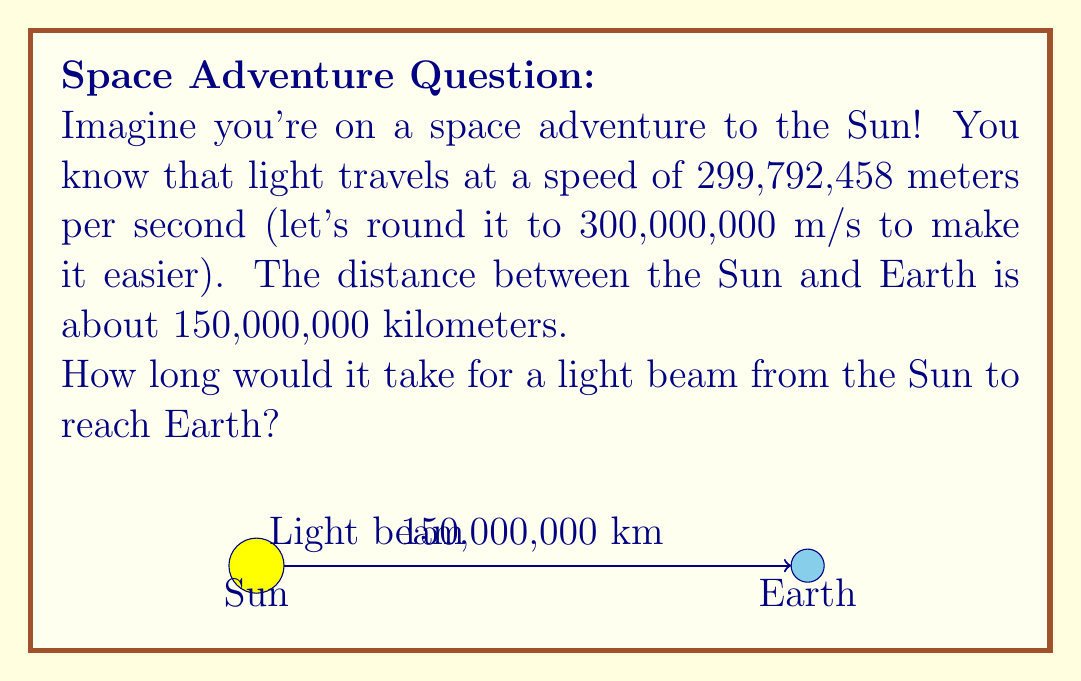Help me with this question. Let's break this down into simple steps:

1. We know that:
   - Speed of light = 300,000,000 meters per second
   - Distance from Sun to Earth = 150,000,000 kilometers

2. First, we need to convert the distance to meters:
   $150,000,000 \text{ km} = 150,000,000,000 \text{ m}$ (we added three more zeros)

3. Now, we can use the formula: 
   $\text{Time} = \frac{\text{Distance}}{\text{Speed}}$

4. Let's plug in our numbers:
   $$\text{Time} = \frac{150,000,000,000 \text{ m}}{300,000,000 \text{ m/s}}$$

5. Simplify by cancelling out zeros:
   $$\text{Time} = \frac{150,000,000,000}{300,000,000} = 500 \text{ seconds}$$

6. To make this easier to understand, let's convert 500 seconds to minutes:
   $500 \text{ seconds} = 500 \div 60 \approx 8.33 \text{ minutes}$

So, it takes about 8 minutes and 20 seconds for light to travel from the Sun to Earth!
Answer: 8 minutes and 20 seconds 